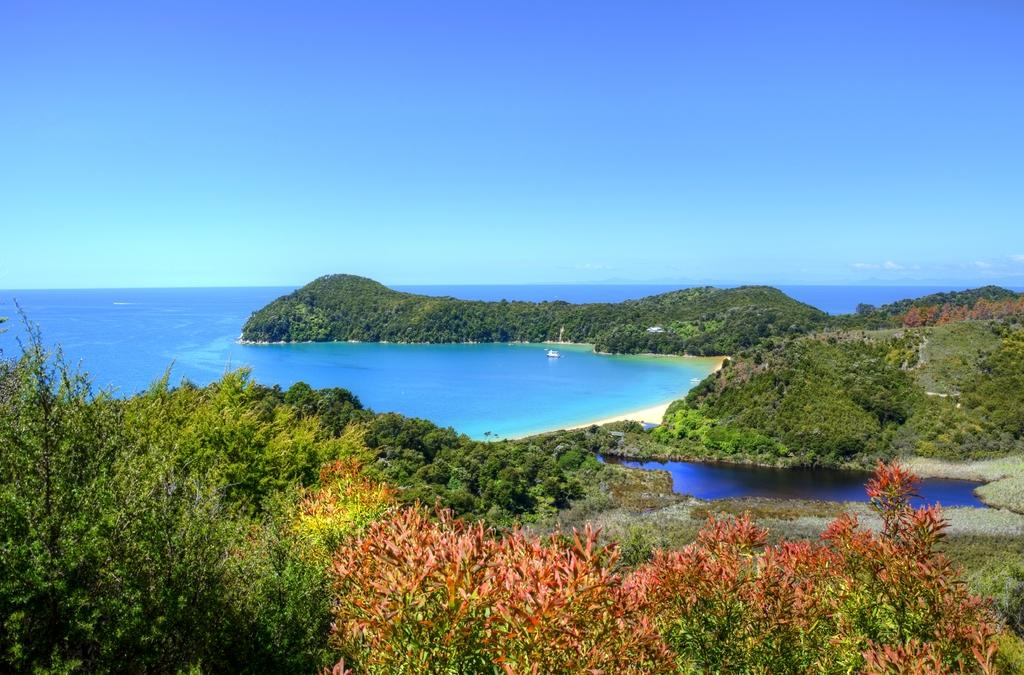Where was the image taken? The image was clicked outside the city. What can be seen in the foreground of the image? There are plants in the foreground of the image. What is the main feature in the center of the image? There is a water body in the center of the image. What is visible in the background of the image? The sky is visible in the background of the image. What type of cough does the water body have in the image? The water body does not have a cough in the image; it is a natural body of water. 